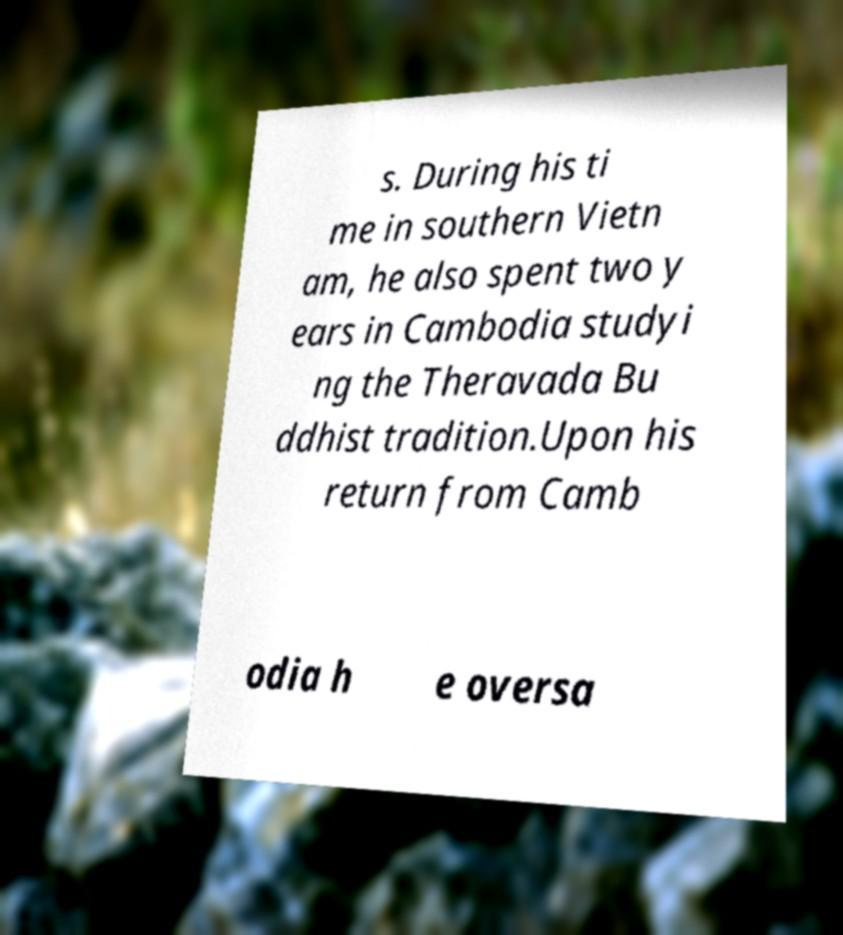What messages or text are displayed in this image? I need them in a readable, typed format. s. During his ti me in southern Vietn am, he also spent two y ears in Cambodia studyi ng the Theravada Bu ddhist tradition.Upon his return from Camb odia h e oversa 